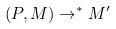<formula> <loc_0><loc_0><loc_500><loc_500>( P , M ) \rightarrow ^ { * } M ^ { \prime }</formula> 